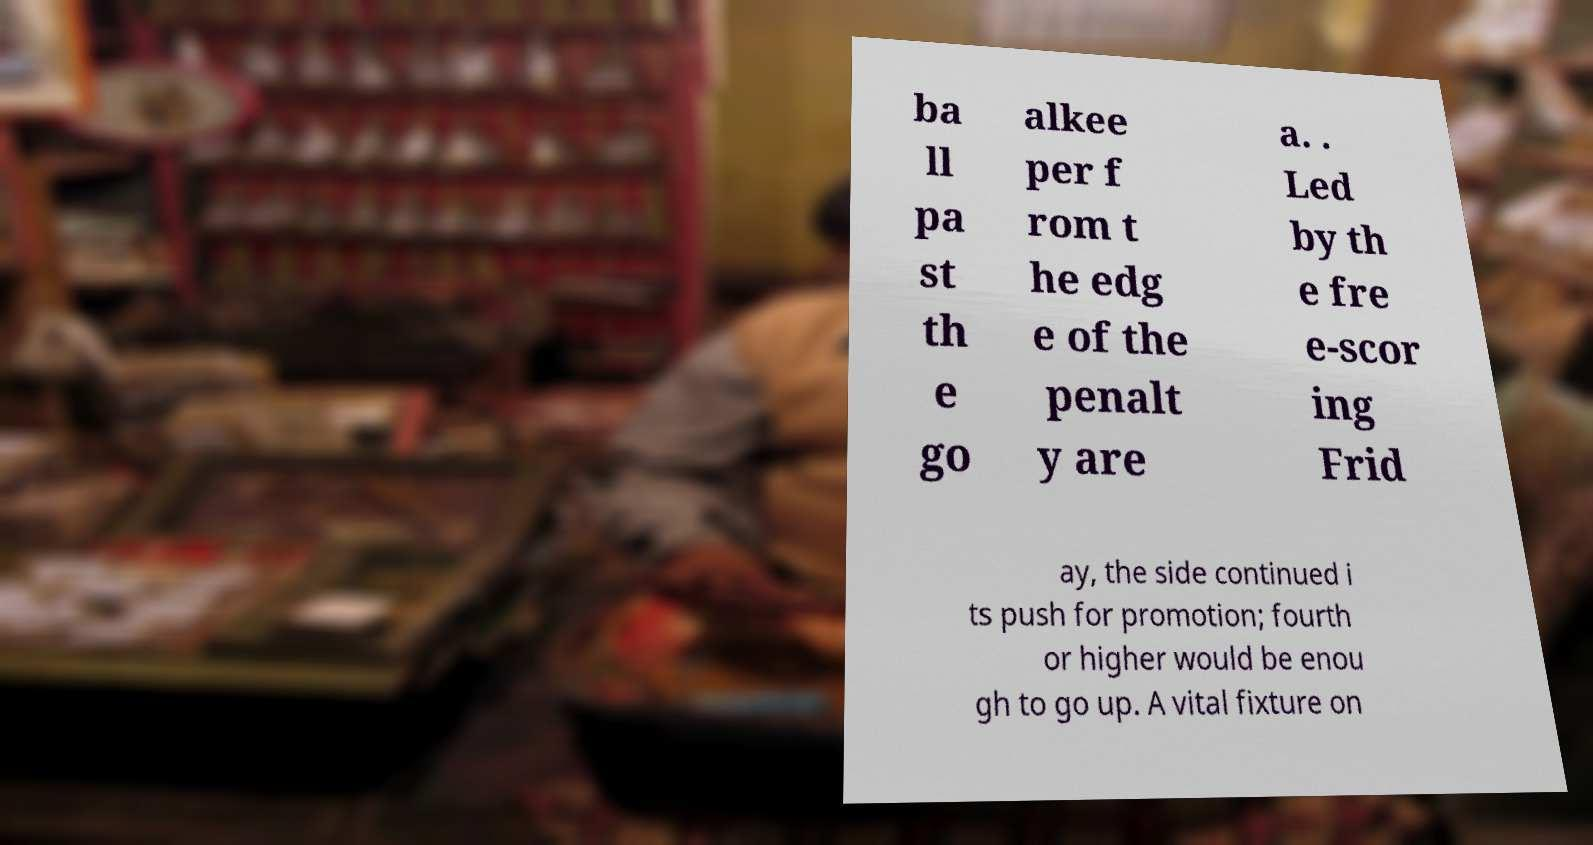Could you assist in decoding the text presented in this image and type it out clearly? ba ll pa st th e go alkee per f rom t he edg e of the penalt y are a. . Led by th e fre e-scor ing Frid ay, the side continued i ts push for promotion; fourth or higher would be enou gh to go up. A vital fixture on 